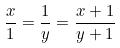Convert formula to latex. <formula><loc_0><loc_0><loc_500><loc_500>\frac { x } { 1 } = \frac { 1 } { y } = \frac { x + 1 } { y + 1 }</formula> 